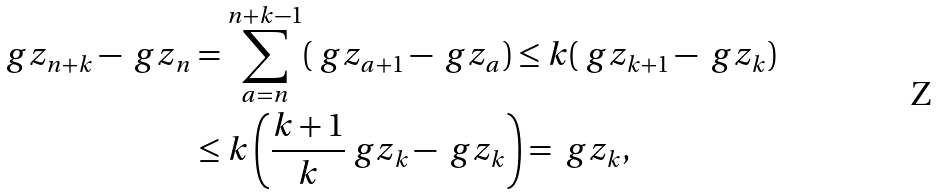<formula> <loc_0><loc_0><loc_500><loc_500>\ g z _ { n + k } - \ g z _ { n } & = \sum _ { a = n } ^ { n + k - 1 } ( \ g z _ { a + 1 } - \ g z _ { a } ) \leq k ( \ g z _ { k + 1 } - \ g z _ { k } ) \\ & \leq k \left ( \frac { k + 1 } { k } \ g z _ { k } - \ g z _ { k } \right ) = \ g z _ { k } ,</formula> 